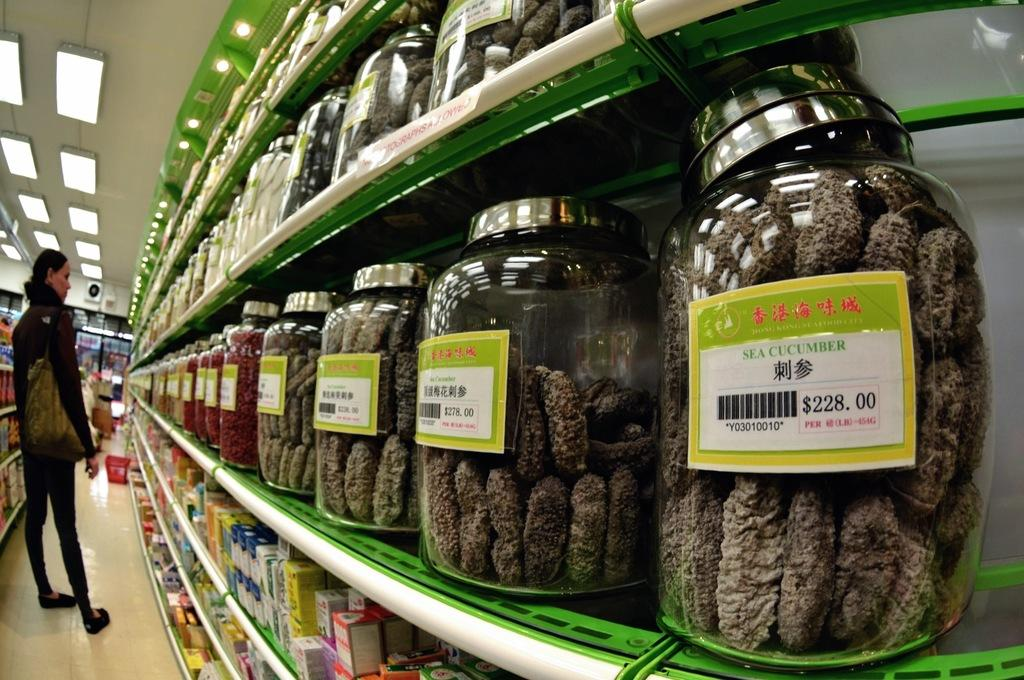<image>
Relay a brief, clear account of the picture shown. A jar of Sea Cucumbers sits on a shelf with other jars. 